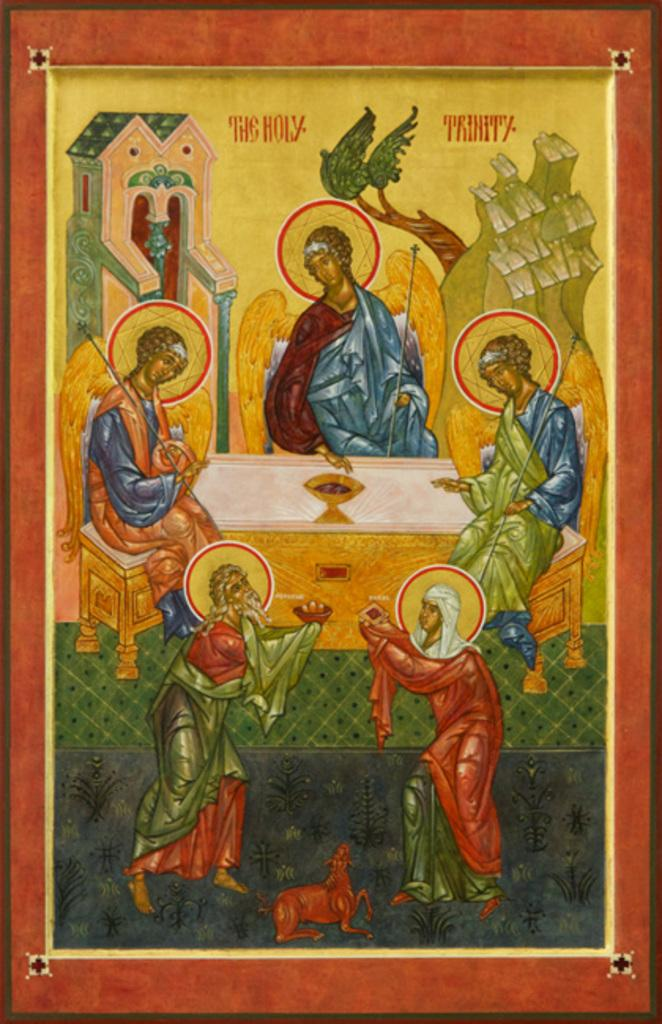What is the main subject of the image? There is a painting in the image. What word is written on the rock in the image? There is no rock or word present in the image; it only features a painting. 